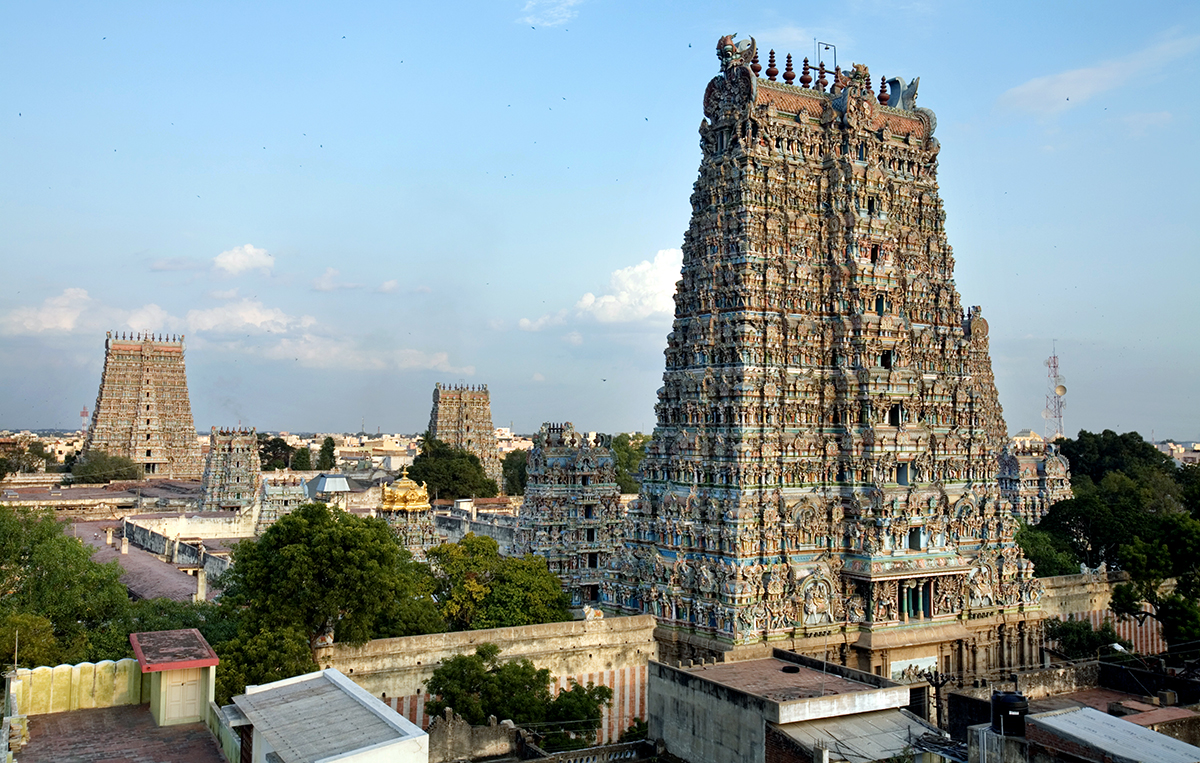Could you tell me more about the historical significance of the Meenakshi Amman Temple? Certainly! The Meenakshi Amman Temple is not only an architectural marvel but also a deep-seated symbol of the Tamil Nadu’s cultural and religious history. Dating back to the 6th century CE, the temple was rebuilt in the 16th century and has been a pivotal center for worship and pilgrimage. It honors Goddess Meenakshi, considered a form of Parvati, with magnificent rituals and festivals that attract millions of devotees annually, reflecting its enduring religious importance. 